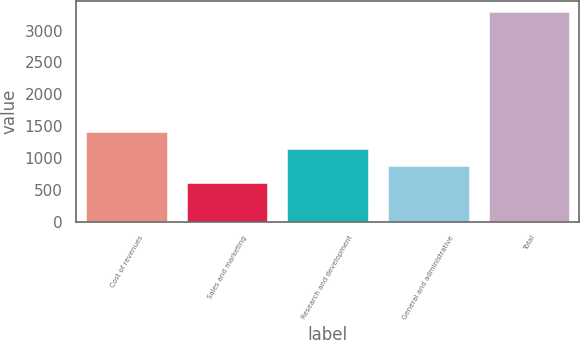Convert chart. <chart><loc_0><loc_0><loc_500><loc_500><bar_chart><fcel>Cost of revenues<fcel>Sales and marketing<fcel>Research and development<fcel>General and administrative<fcel>Total<nl><fcel>1414<fcel>607<fcel>1145<fcel>876<fcel>3297<nl></chart> 